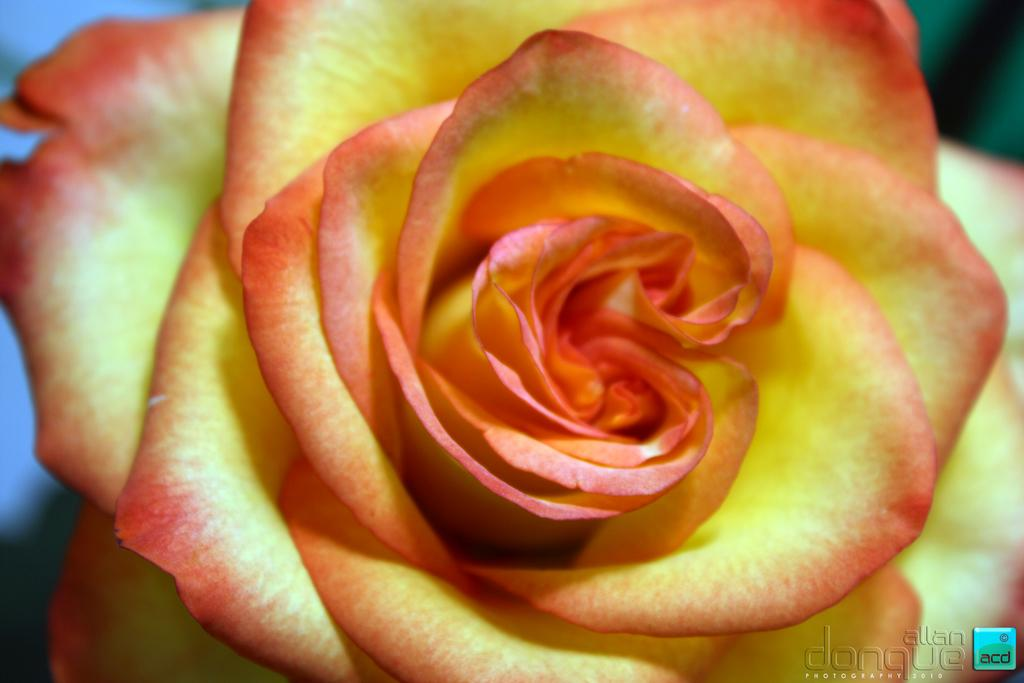What is the main subject of the image? There is a rose flower in the middle of the image. Can you describe any additional features of the image? There is a watermark in the bottom right-hand side of the image. How many beds are visible in the image? There are no beds present in the image; it features a rose flower and a watermark. What type of achievement is the rose flower celebrating in the image? The image does not depict an achievement or celebration; it simply shows a rose flower and a watermark. 